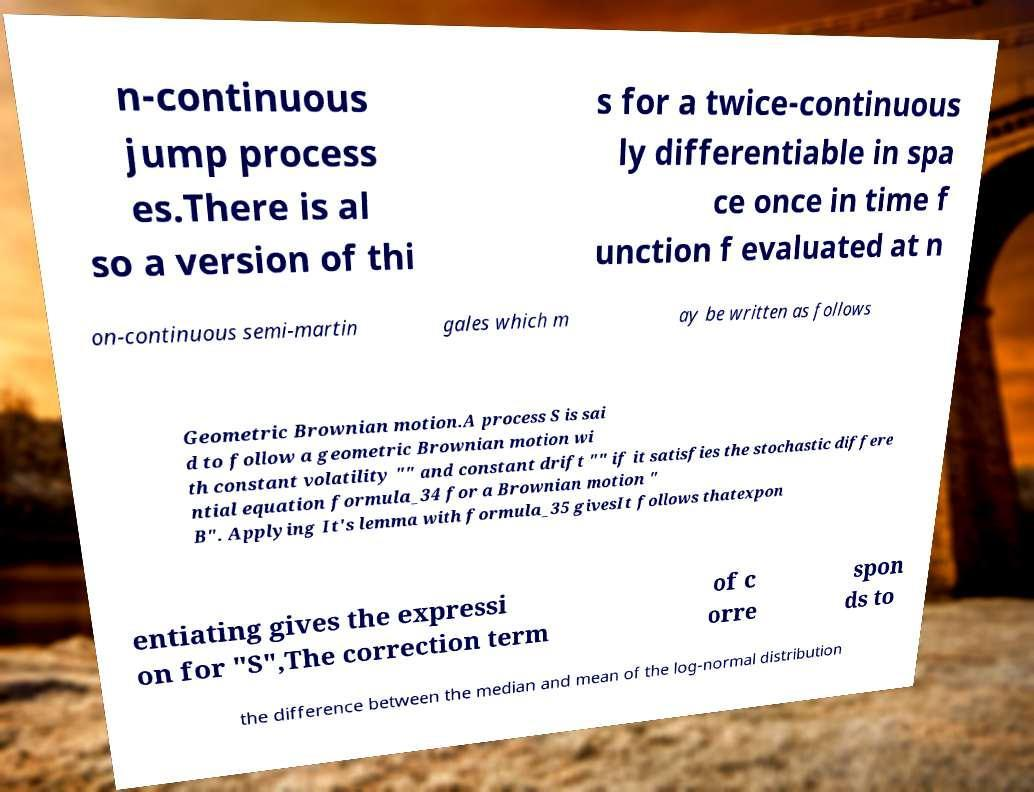Could you extract and type out the text from this image? n-continuous jump process es.There is al so a version of thi s for a twice-continuous ly differentiable in spa ce once in time f unction f evaluated at n on-continuous semi-martin gales which m ay be written as follows Geometric Brownian motion.A process S is sai d to follow a geometric Brownian motion wi th constant volatility "" and constant drift "" if it satisfies the stochastic differe ntial equation formula_34 for a Brownian motion " B". Applying It's lemma with formula_35 givesIt follows thatexpon entiating gives the expressi on for "S",The correction term of c orre spon ds to the difference between the median and mean of the log-normal distribution 